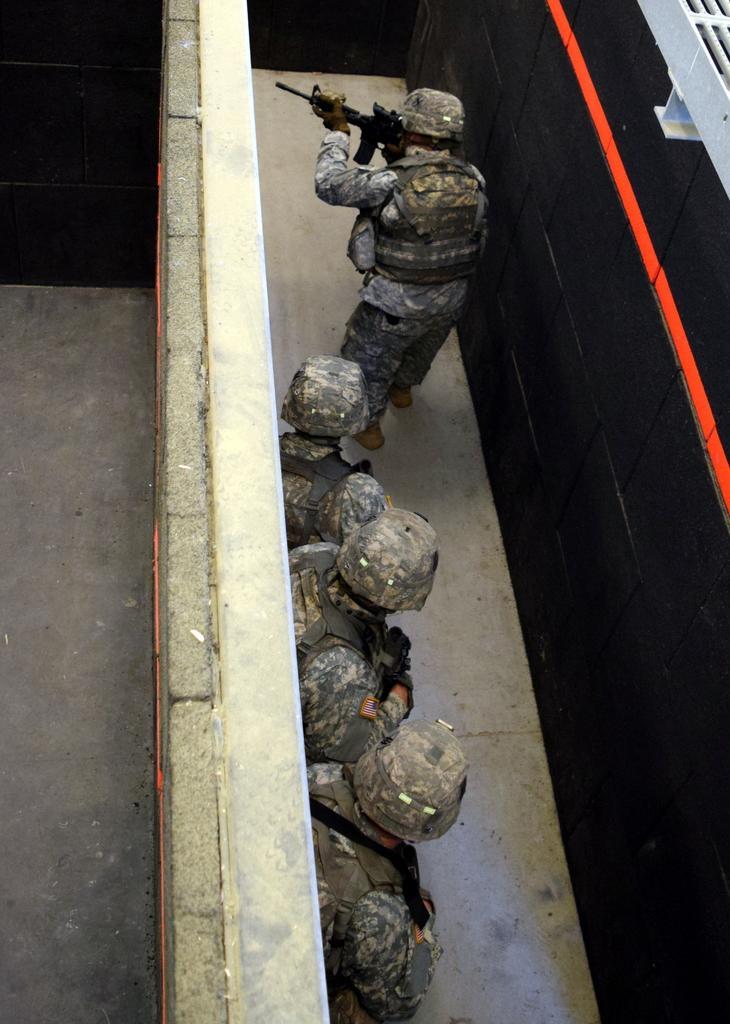Could you give a brief overview of what you see in this image? In this picture we can see some army people are standing between the walls. 